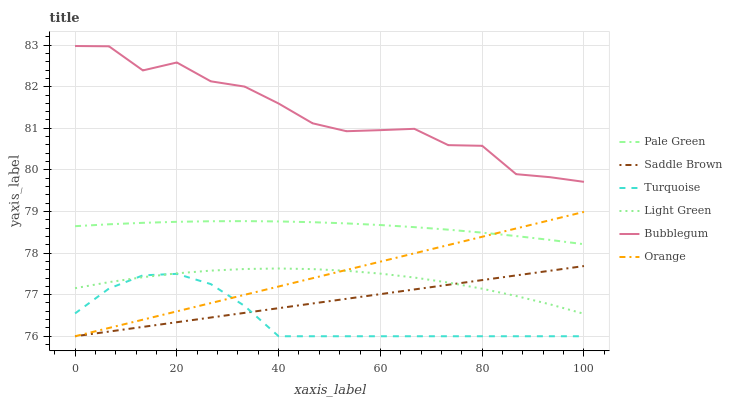Does Turquoise have the minimum area under the curve?
Answer yes or no. Yes. Does Bubblegum have the maximum area under the curve?
Answer yes or no. Yes. Does Pale Green have the minimum area under the curve?
Answer yes or no. No. Does Pale Green have the maximum area under the curve?
Answer yes or no. No. Is Saddle Brown the smoothest?
Answer yes or no. Yes. Is Bubblegum the roughest?
Answer yes or no. Yes. Is Pale Green the smoothest?
Answer yes or no. No. Is Pale Green the roughest?
Answer yes or no. No. Does Turquoise have the lowest value?
Answer yes or no. Yes. Does Pale Green have the lowest value?
Answer yes or no. No. Does Bubblegum have the highest value?
Answer yes or no. Yes. Does Pale Green have the highest value?
Answer yes or no. No. Is Light Green less than Bubblegum?
Answer yes or no. Yes. Is Pale Green greater than Saddle Brown?
Answer yes or no. Yes. Does Turquoise intersect Light Green?
Answer yes or no. Yes. Is Turquoise less than Light Green?
Answer yes or no. No. Is Turquoise greater than Light Green?
Answer yes or no. No. Does Light Green intersect Bubblegum?
Answer yes or no. No. 